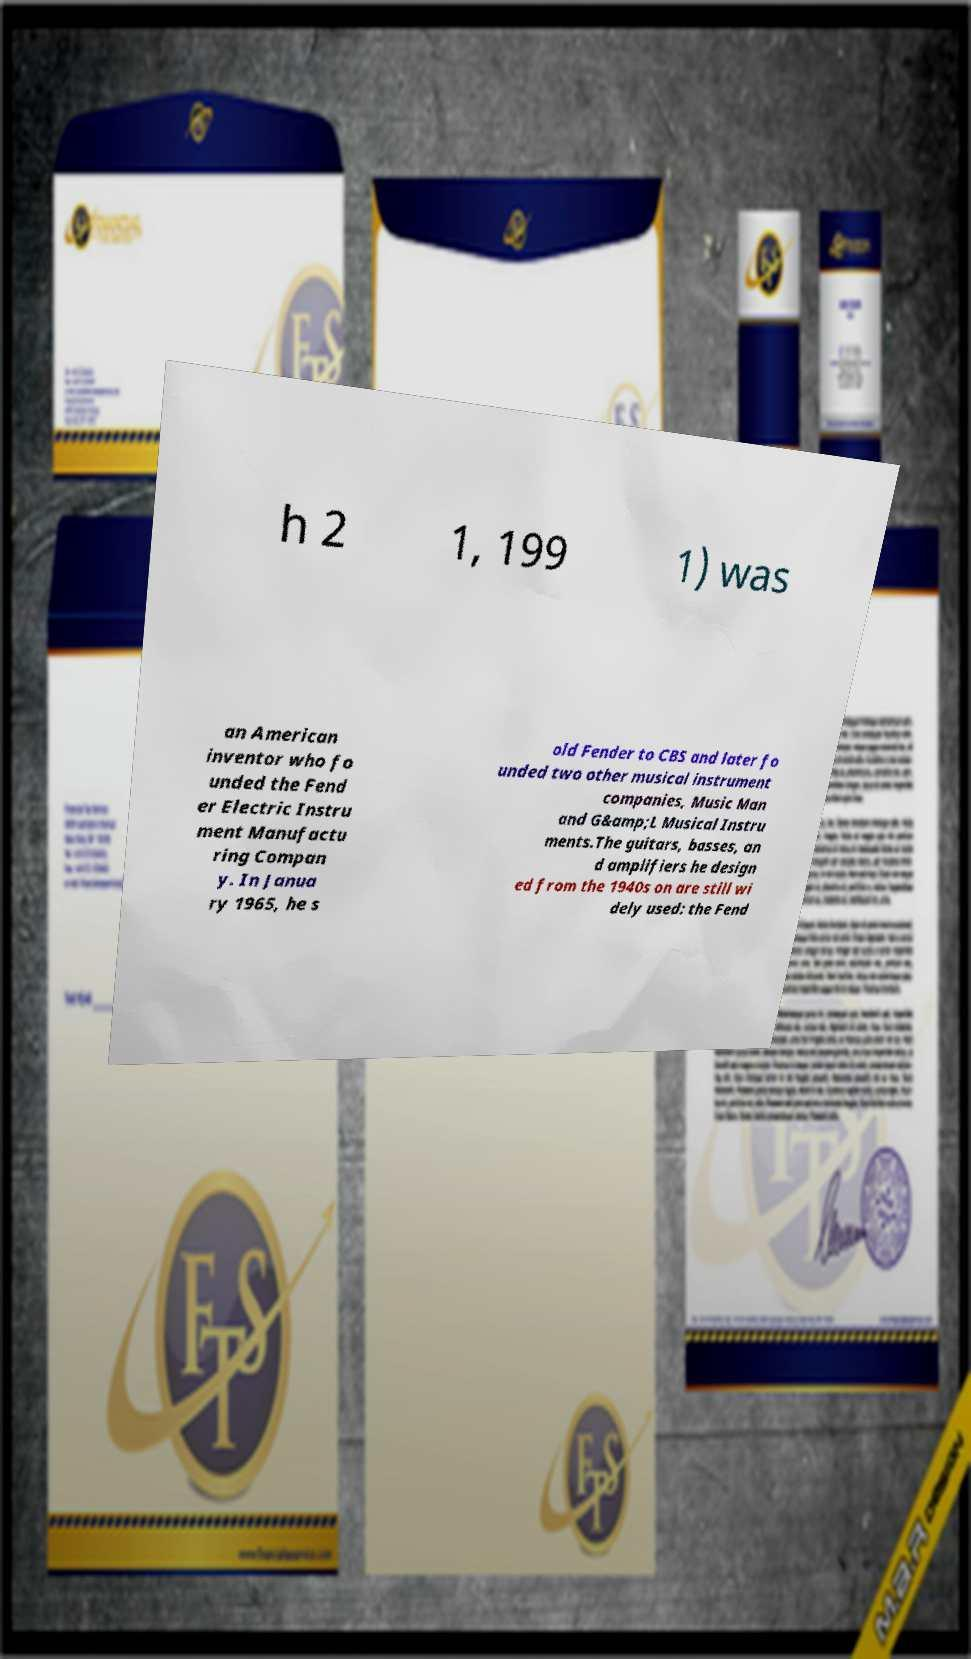Could you extract and type out the text from this image? h 2 1, 199 1) was an American inventor who fo unded the Fend er Electric Instru ment Manufactu ring Compan y. In Janua ry 1965, he s old Fender to CBS and later fo unded two other musical instrument companies, Music Man and G&amp;L Musical Instru ments.The guitars, basses, an d amplifiers he design ed from the 1940s on are still wi dely used: the Fend 